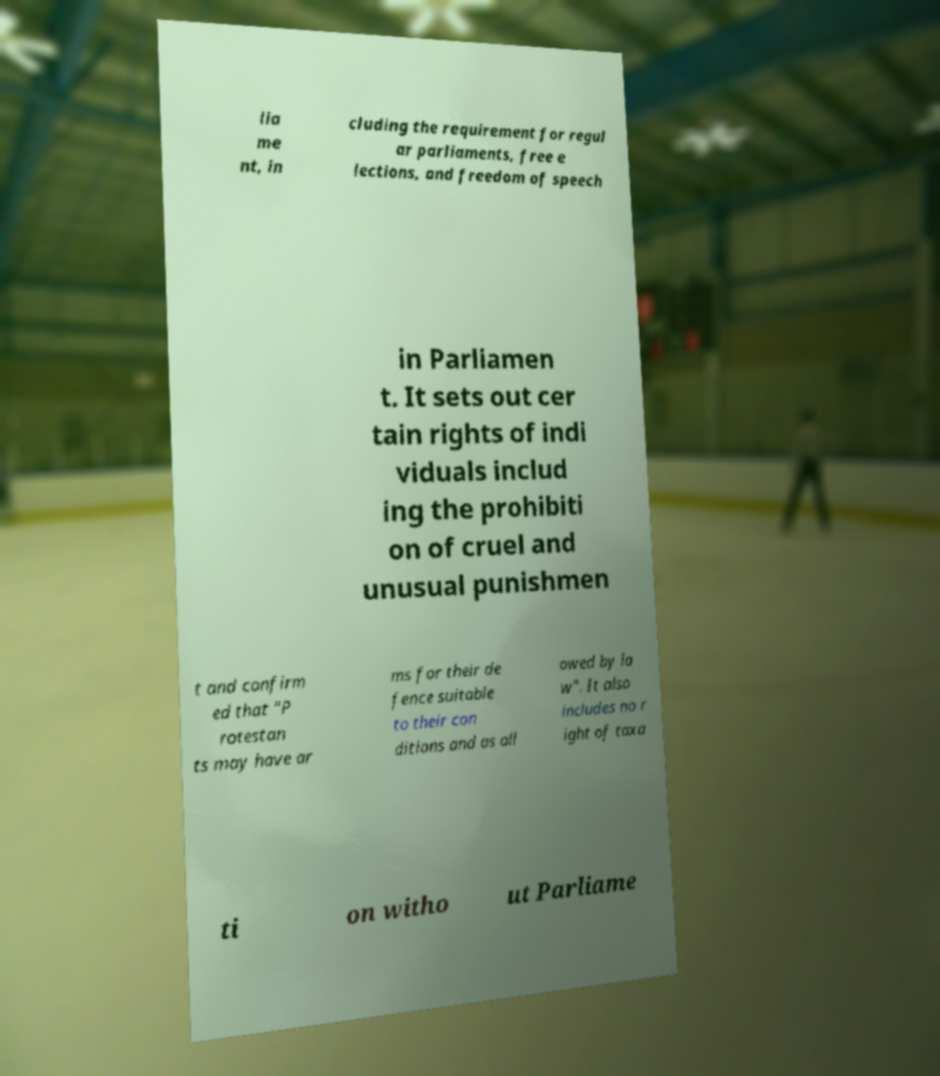For documentation purposes, I need the text within this image transcribed. Could you provide that? lia me nt, in cluding the requirement for regul ar parliaments, free e lections, and freedom of speech in Parliamen t. It sets out cer tain rights of indi viduals includ ing the prohibiti on of cruel and unusual punishmen t and confirm ed that "P rotestan ts may have ar ms for their de fence suitable to their con ditions and as all owed by la w". It also includes no r ight of taxa ti on witho ut Parliame 